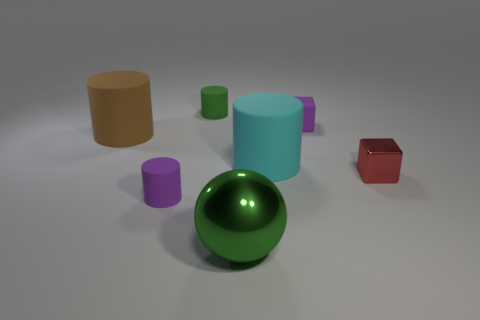Add 2 small green metallic spheres. How many objects exist? 9 Subtract all blocks. How many objects are left? 5 Subtract all cyan matte objects. Subtract all green rubber cylinders. How many objects are left? 5 Add 7 big cyan matte objects. How many big cyan matte objects are left? 8 Add 2 large yellow shiny spheres. How many large yellow shiny spheres exist? 2 Subtract 0 red cylinders. How many objects are left? 7 